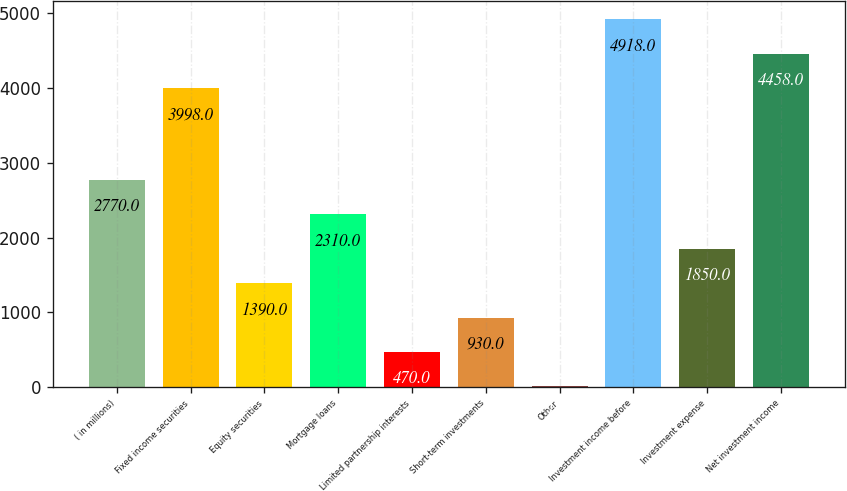Convert chart. <chart><loc_0><loc_0><loc_500><loc_500><bar_chart><fcel>( in millions)<fcel>Fixed income securities<fcel>Equity securities<fcel>Mortgage loans<fcel>Limited partnership interests<fcel>Short-term investments<fcel>Other<fcel>Investment income before<fcel>Investment expense<fcel>Net investment income<nl><fcel>2770<fcel>3998<fcel>1390<fcel>2310<fcel>470<fcel>930<fcel>10<fcel>4918<fcel>1850<fcel>4458<nl></chart> 